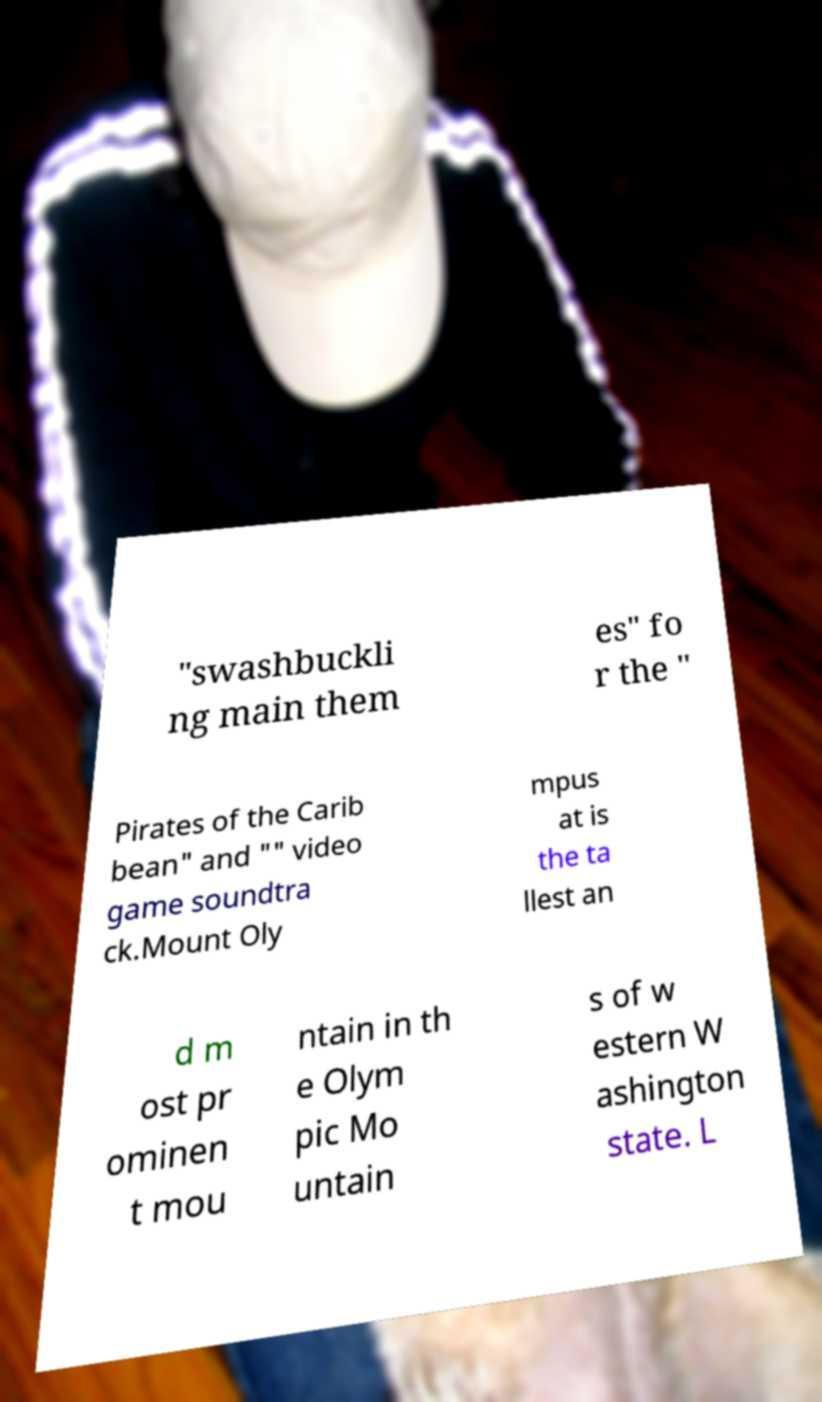What messages or text are displayed in this image? I need them in a readable, typed format. "swashbuckli ng main them es" fo r the " Pirates of the Carib bean" and "" video game soundtra ck.Mount Oly mpus at is the ta llest an d m ost pr ominen t mou ntain in th e Olym pic Mo untain s of w estern W ashington state. L 